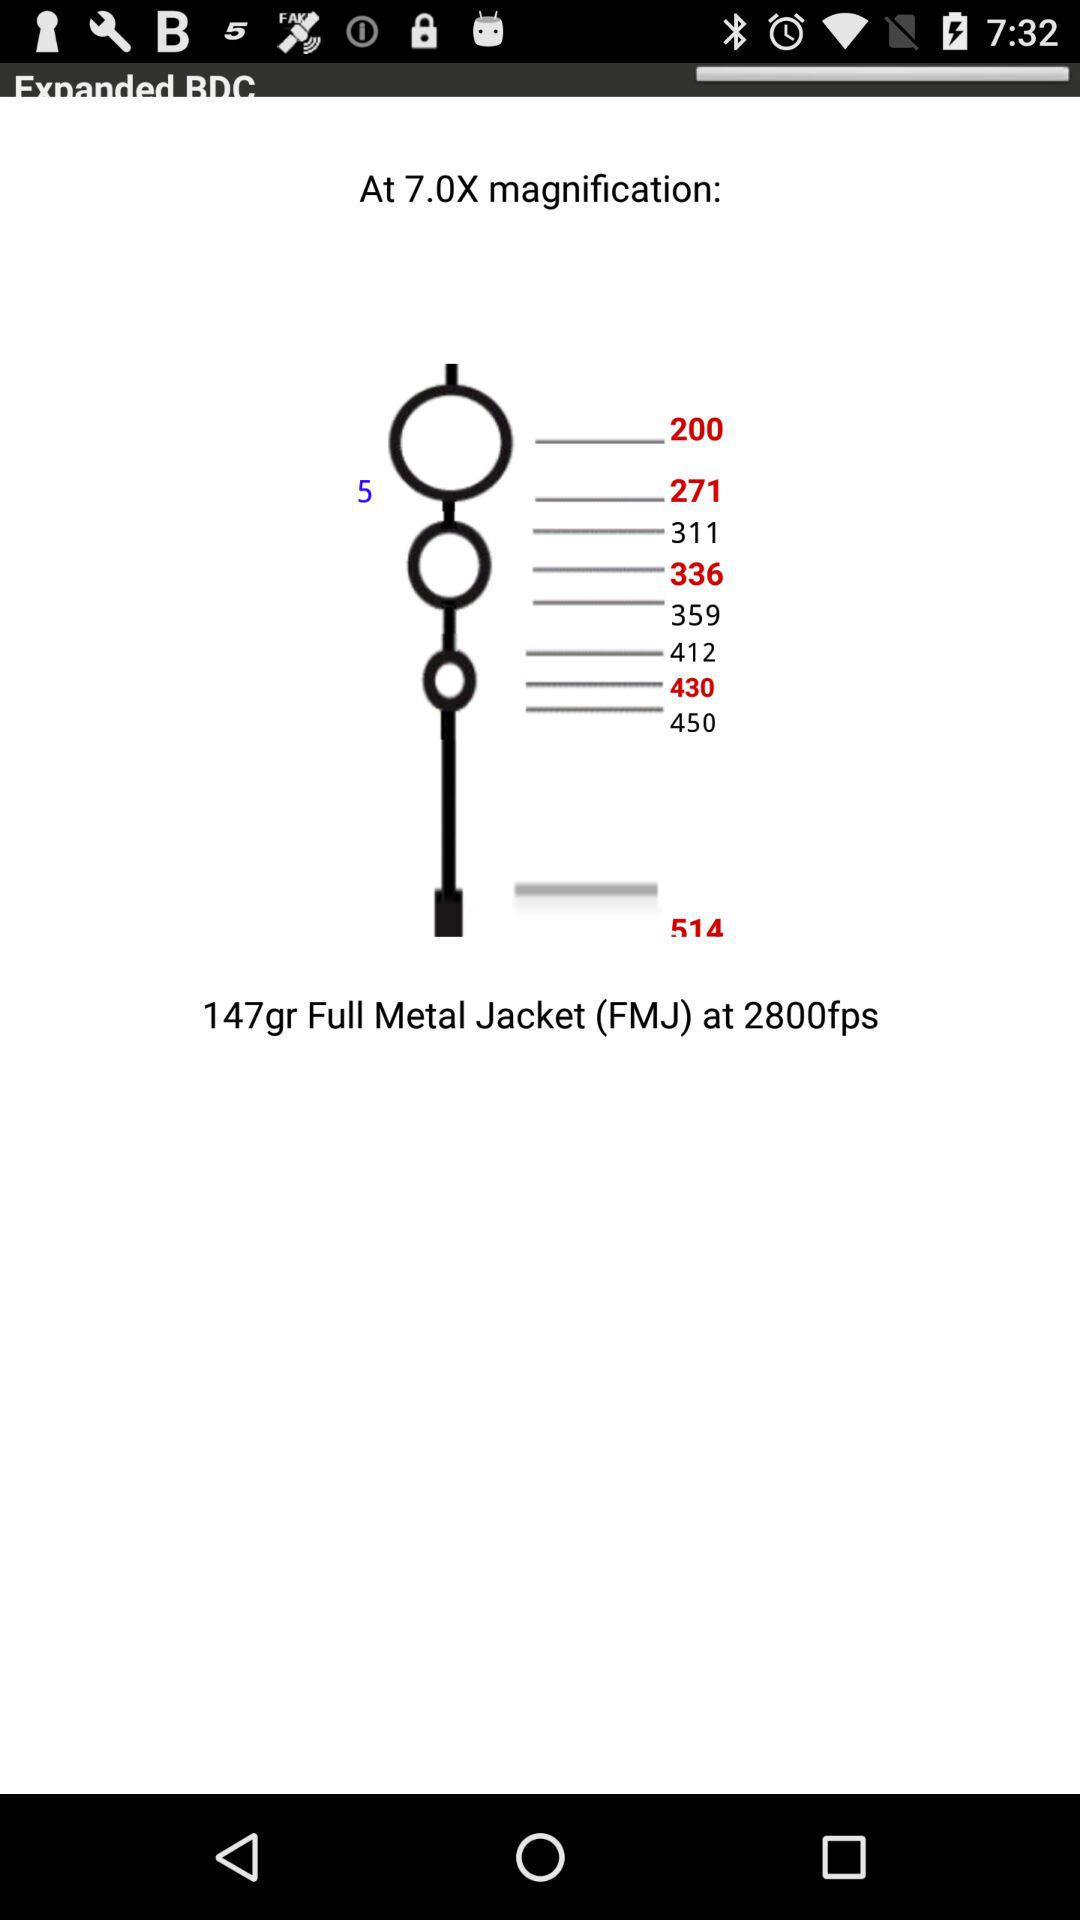What is the minimum magnification?
When the provided information is insufficient, respond with <no answer>. <no answer> 